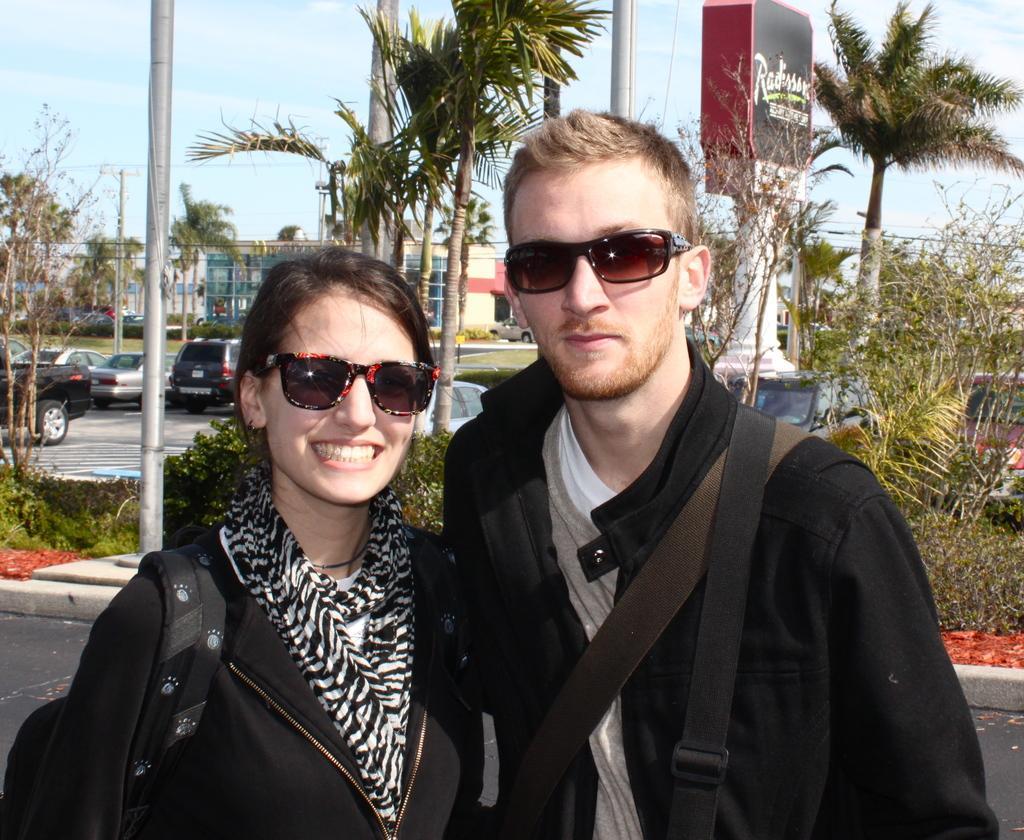How would you summarize this image in a sentence or two? As we can see in the image there are trees, banner, plants, vehicles, buildings and at the top there is sky. In the front there are two people two people wearing black color dresses. 